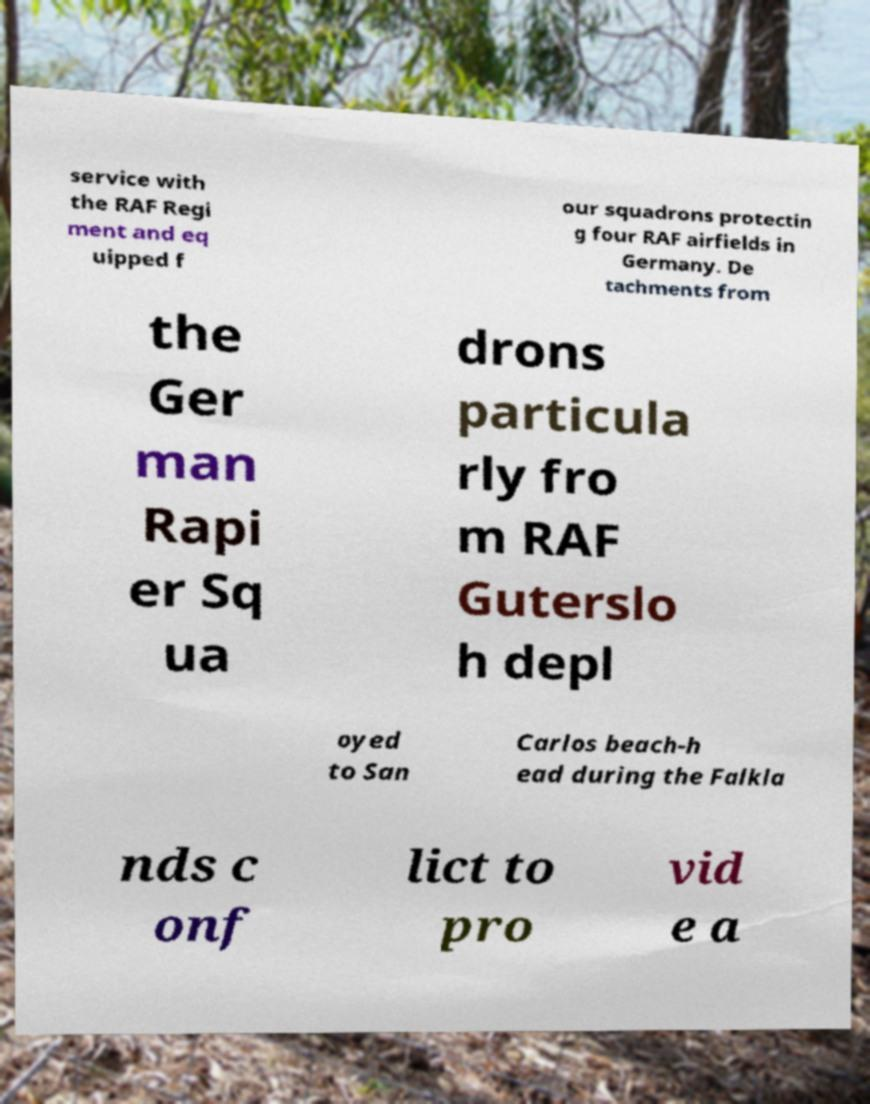Please read and relay the text visible in this image. What does it say? service with the RAF Regi ment and eq uipped f our squadrons protectin g four RAF airfields in Germany. De tachments from the Ger man Rapi er Sq ua drons particula rly fro m RAF Guterslo h depl oyed to San Carlos beach-h ead during the Falkla nds c onf lict to pro vid e a 